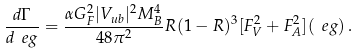Convert formula to latex. <formula><loc_0><loc_0><loc_500><loc_500>\frac { d \Gamma } { d \ e g } = \frac { \alpha G _ { F } ^ { 2 } | V _ { u b } | ^ { 2 } M _ { B } ^ { 4 } } { 4 8 \pi ^ { 2 } } R ( 1 - R ) ^ { 3 } [ F ^ { 2 } _ { V } + F _ { A } ^ { 2 } ] ( \ e g ) \, .</formula> 